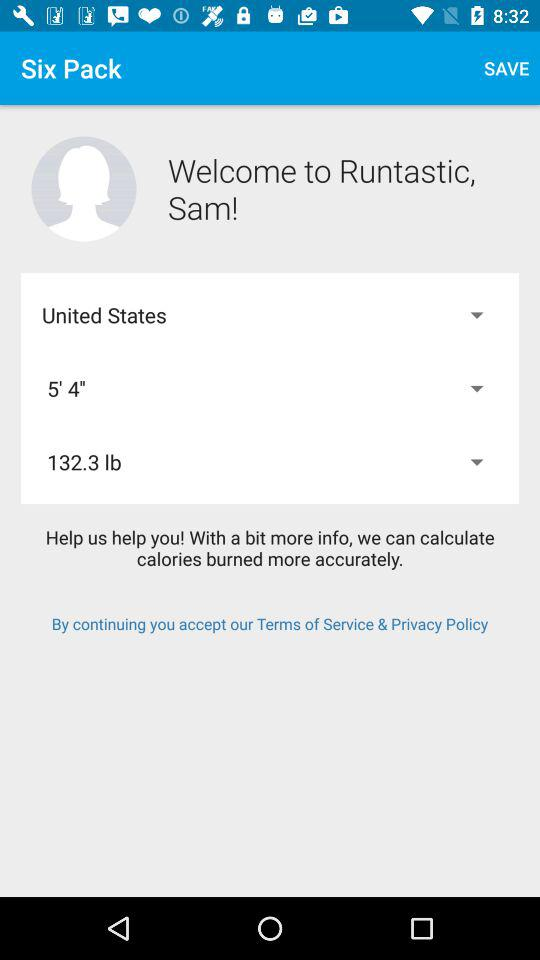What is the height? The height is 5' 4". 